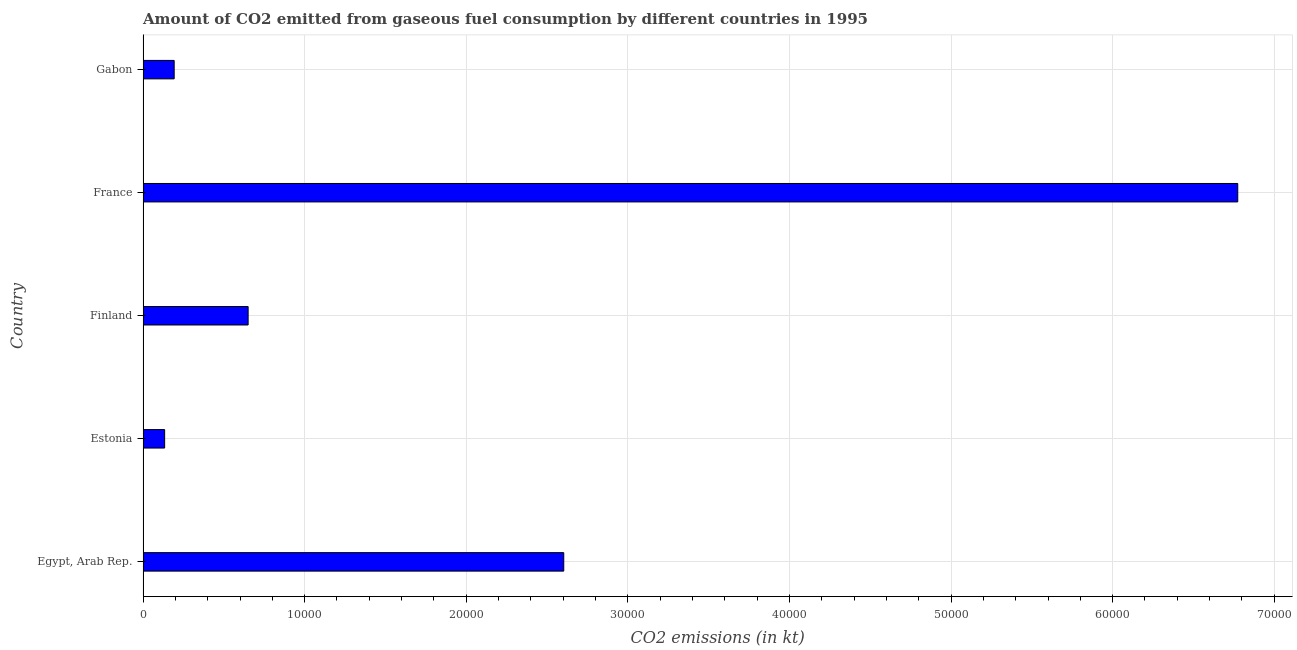Does the graph contain any zero values?
Make the answer very short. No. What is the title of the graph?
Ensure brevity in your answer.  Amount of CO2 emitted from gaseous fuel consumption by different countries in 1995. What is the label or title of the X-axis?
Your answer should be compact. CO2 emissions (in kt). What is the label or title of the Y-axis?
Give a very brief answer. Country. What is the co2 emissions from gaseous fuel consumption in Estonia?
Offer a terse response. 1334.79. Across all countries, what is the maximum co2 emissions from gaseous fuel consumption?
Your answer should be compact. 6.77e+04. Across all countries, what is the minimum co2 emissions from gaseous fuel consumption?
Offer a terse response. 1334.79. In which country was the co2 emissions from gaseous fuel consumption maximum?
Make the answer very short. France. In which country was the co2 emissions from gaseous fuel consumption minimum?
Provide a short and direct response. Estonia. What is the sum of the co2 emissions from gaseous fuel consumption?
Keep it short and to the point. 1.04e+05. What is the difference between the co2 emissions from gaseous fuel consumption in Finland and Gabon?
Your answer should be very brief. 4576.42. What is the average co2 emissions from gaseous fuel consumption per country?
Keep it short and to the point. 2.07e+04. What is the median co2 emissions from gaseous fuel consumption?
Give a very brief answer. 6501.59. In how many countries, is the co2 emissions from gaseous fuel consumption greater than 18000 kt?
Offer a terse response. 2. What is the ratio of the co2 emissions from gaseous fuel consumption in Finland to that in France?
Provide a short and direct response. 0.1. What is the difference between the highest and the second highest co2 emissions from gaseous fuel consumption?
Keep it short and to the point. 4.17e+04. What is the difference between the highest and the lowest co2 emissions from gaseous fuel consumption?
Provide a short and direct response. 6.64e+04. How many bars are there?
Provide a succinct answer. 5. Are all the bars in the graph horizontal?
Your answer should be very brief. Yes. How many countries are there in the graph?
Offer a very short reply. 5. What is the difference between two consecutive major ticks on the X-axis?
Offer a terse response. 10000. Are the values on the major ticks of X-axis written in scientific E-notation?
Keep it short and to the point. No. What is the CO2 emissions (in kt) of Egypt, Arab Rep.?
Your answer should be compact. 2.60e+04. What is the CO2 emissions (in kt) in Estonia?
Provide a short and direct response. 1334.79. What is the CO2 emissions (in kt) of Finland?
Make the answer very short. 6501.59. What is the CO2 emissions (in kt) of France?
Make the answer very short. 6.77e+04. What is the CO2 emissions (in kt) of Gabon?
Provide a succinct answer. 1925.17. What is the difference between the CO2 emissions (in kt) in Egypt, Arab Rep. and Estonia?
Your answer should be very brief. 2.47e+04. What is the difference between the CO2 emissions (in kt) in Egypt, Arab Rep. and Finland?
Ensure brevity in your answer.  1.95e+04. What is the difference between the CO2 emissions (in kt) in Egypt, Arab Rep. and France?
Your answer should be very brief. -4.17e+04. What is the difference between the CO2 emissions (in kt) in Egypt, Arab Rep. and Gabon?
Provide a short and direct response. 2.41e+04. What is the difference between the CO2 emissions (in kt) in Estonia and Finland?
Make the answer very short. -5166.8. What is the difference between the CO2 emissions (in kt) in Estonia and France?
Offer a terse response. -6.64e+04. What is the difference between the CO2 emissions (in kt) in Estonia and Gabon?
Keep it short and to the point. -590.39. What is the difference between the CO2 emissions (in kt) in Finland and France?
Offer a terse response. -6.12e+04. What is the difference between the CO2 emissions (in kt) in Finland and Gabon?
Offer a terse response. 4576.42. What is the difference between the CO2 emissions (in kt) in France and Gabon?
Ensure brevity in your answer.  6.58e+04. What is the ratio of the CO2 emissions (in kt) in Egypt, Arab Rep. to that in Estonia?
Provide a succinct answer. 19.5. What is the ratio of the CO2 emissions (in kt) in Egypt, Arab Rep. to that in Finland?
Provide a succinct answer. 4. What is the ratio of the CO2 emissions (in kt) in Egypt, Arab Rep. to that in France?
Ensure brevity in your answer.  0.38. What is the ratio of the CO2 emissions (in kt) in Egypt, Arab Rep. to that in Gabon?
Keep it short and to the point. 13.52. What is the ratio of the CO2 emissions (in kt) in Estonia to that in Finland?
Your response must be concise. 0.2. What is the ratio of the CO2 emissions (in kt) in Estonia to that in Gabon?
Your response must be concise. 0.69. What is the ratio of the CO2 emissions (in kt) in Finland to that in France?
Make the answer very short. 0.1. What is the ratio of the CO2 emissions (in kt) in Finland to that in Gabon?
Ensure brevity in your answer.  3.38. What is the ratio of the CO2 emissions (in kt) in France to that in Gabon?
Offer a terse response. 35.19. 